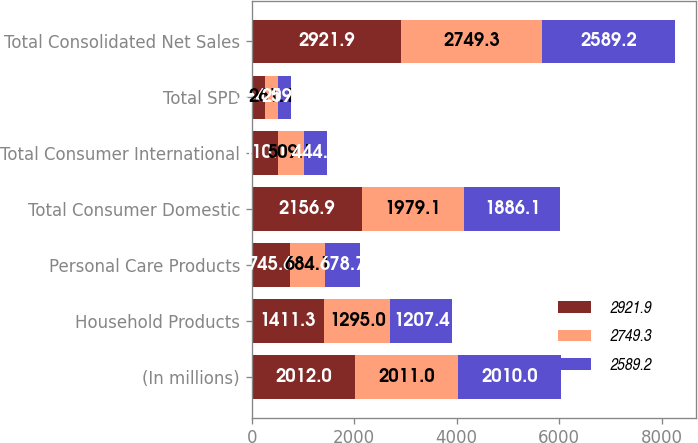Convert chart to OTSL. <chart><loc_0><loc_0><loc_500><loc_500><stacked_bar_chart><ecel><fcel>(In millions)<fcel>Household Products<fcel>Personal Care Products<fcel>Total Consumer Domestic<fcel>Total Consumer International<fcel>Total SPD<fcel>Total Consolidated Net Sales<nl><fcel>2921.9<fcel>2012<fcel>1411.3<fcel>745.6<fcel>2156.9<fcel>510.1<fcel>254.9<fcel>2921.9<nl><fcel>2749.3<fcel>2011<fcel>1295<fcel>684.1<fcel>1979.1<fcel>509.1<fcel>261.1<fcel>2749.3<nl><fcel>2589.2<fcel>2010<fcel>1207.4<fcel>678.7<fcel>1886.1<fcel>444<fcel>259.1<fcel>2589.2<nl></chart> 